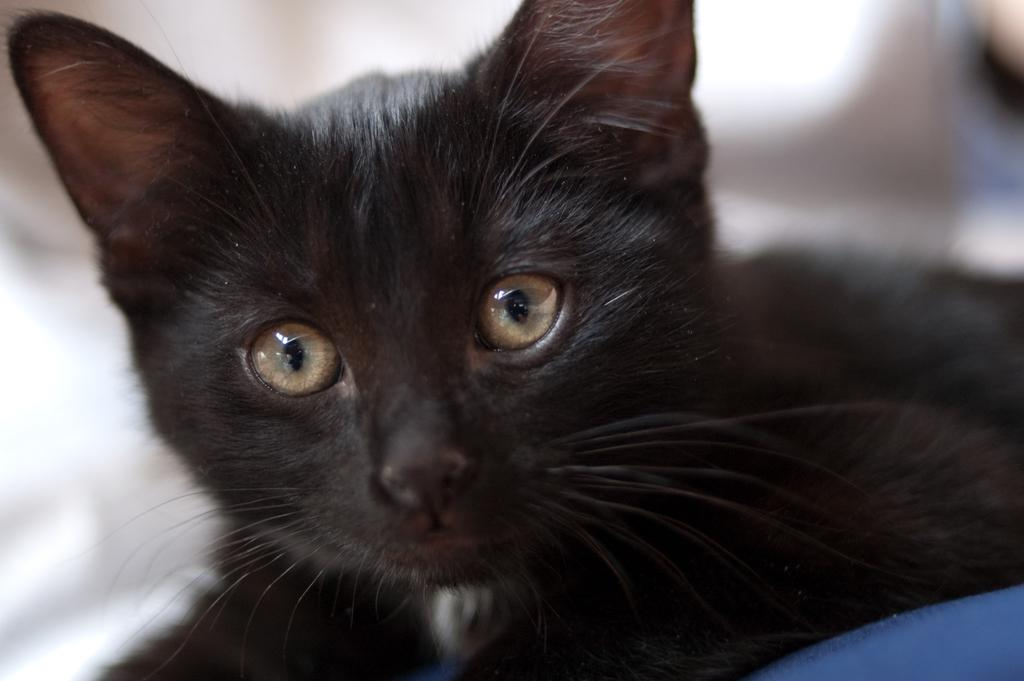What type of animal is in the image? There is a black cat in the image. Where is the cat positioned in the image? The cat is lying on a blue chair or couch. Can you describe the background of the image? The background of the image is blurry. What type of current is flowing through the egg in the image? There is no egg or current present in the image; it features a black cat lying on a blue chair or couch. 